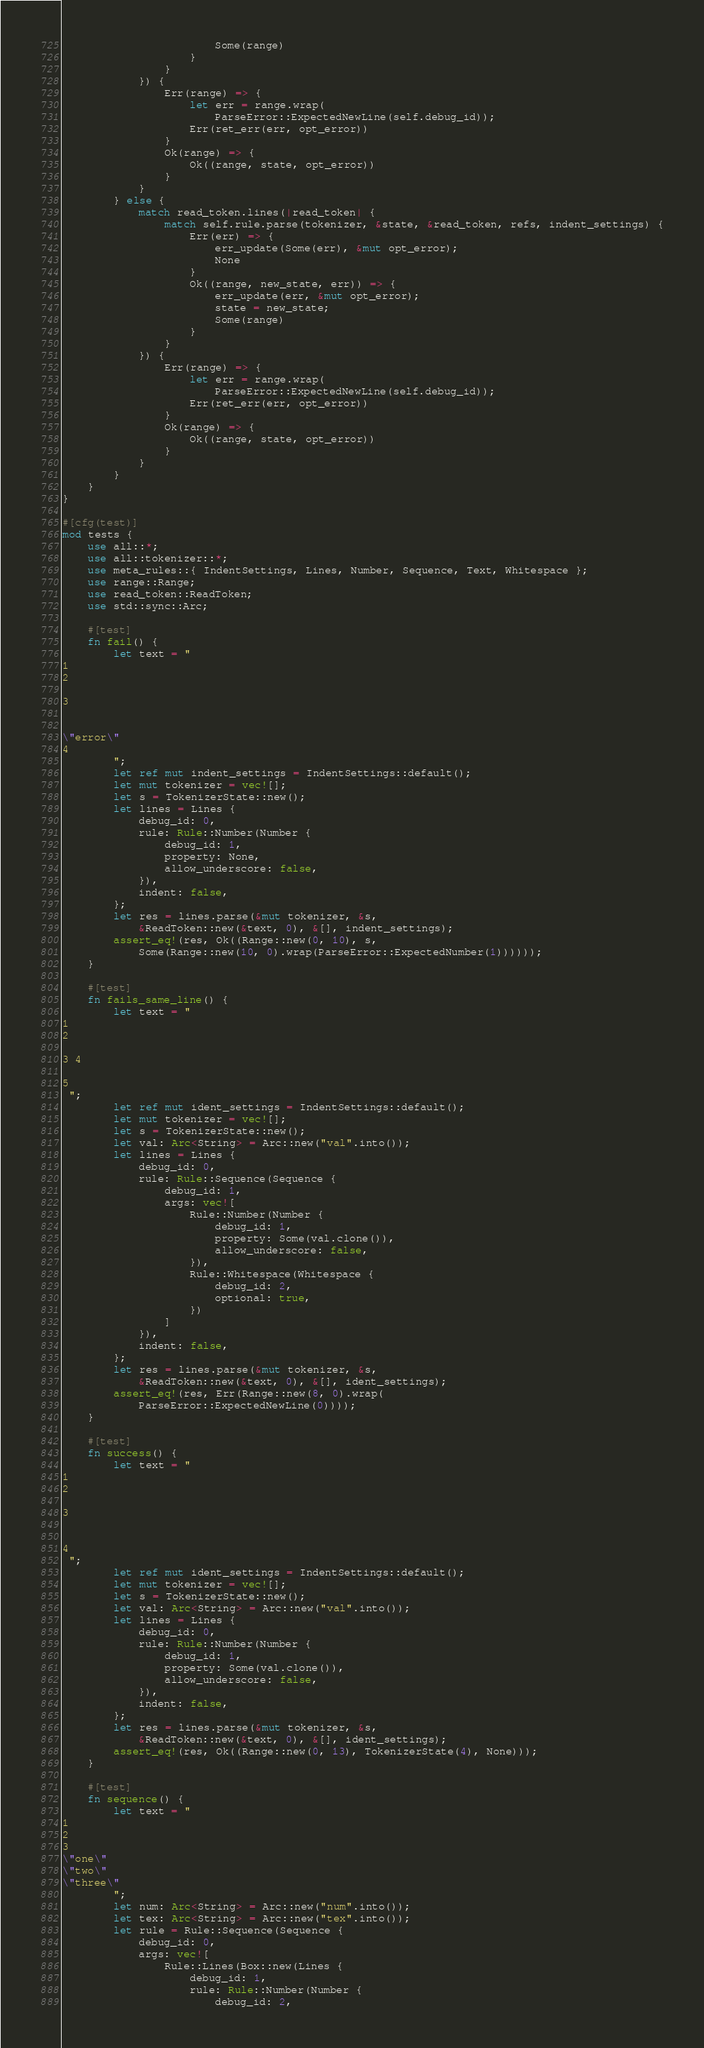<code> <loc_0><loc_0><loc_500><loc_500><_Rust_>                        Some(range)
                    }
                }
            }) {
                Err(range) => {
                    let err = range.wrap(
                        ParseError::ExpectedNewLine(self.debug_id));
                    Err(ret_err(err, opt_error))
                }
                Ok(range) => {
                    Ok((range, state, opt_error))
                }
            }
        } else {
            match read_token.lines(|read_token| {
                match self.rule.parse(tokenizer, &state, &read_token, refs, indent_settings) {
                    Err(err) => {
                        err_update(Some(err), &mut opt_error);
                        None
                    }
                    Ok((range, new_state, err)) => {
                        err_update(err, &mut opt_error);
                        state = new_state;
                        Some(range)
                    }
                }
            }) {
                Err(range) => {
                    let err = range.wrap(
                        ParseError::ExpectedNewLine(self.debug_id));
                    Err(ret_err(err, opt_error))
                }
                Ok(range) => {
                    Ok((range, state, opt_error))
                }
            }
        }
    }
}

#[cfg(test)]
mod tests {
    use all::*;
    use all::tokenizer::*;
    use meta_rules::{ IndentSettings, Lines, Number, Sequence, Text, Whitespace };
    use range::Range;
    use read_token::ReadToken;
    use std::sync::Arc;

    #[test]
    fn fail() {
        let text = "
1
2

3


\"error\"
4
        ";
        let ref mut indent_settings = IndentSettings::default();
        let mut tokenizer = vec![];
        let s = TokenizerState::new();
        let lines = Lines {
            debug_id: 0,
            rule: Rule::Number(Number {
                debug_id: 1,
                property: None,
                allow_underscore: false,
            }),
            indent: false,
        };
        let res = lines.parse(&mut tokenizer, &s,
            &ReadToken::new(&text, 0), &[], indent_settings);
        assert_eq!(res, Ok((Range::new(0, 10), s,
            Some(Range::new(10, 0).wrap(ParseError::ExpectedNumber(1))))));
    }

    #[test]
    fn fails_same_line() {
        let text = "
1
2

3 4

5
 ";
        let ref mut ident_settings = IndentSettings::default();
        let mut tokenizer = vec![];
        let s = TokenizerState::new();
        let val: Arc<String> = Arc::new("val".into());
        let lines = Lines {
            debug_id: 0,
            rule: Rule::Sequence(Sequence {
                debug_id: 1,
                args: vec![
                    Rule::Number(Number {
                        debug_id: 1,
                        property: Some(val.clone()),
                        allow_underscore: false,
                    }),
                    Rule::Whitespace(Whitespace {
                        debug_id: 2,
                        optional: true,
                    })
                ]
            }),
            indent: false,
        };
        let res = lines.parse(&mut tokenizer, &s,
            &ReadToken::new(&text, 0), &[], ident_settings);
        assert_eq!(res, Err(Range::new(8, 0).wrap(
            ParseError::ExpectedNewLine(0))));
    }

    #[test]
    fn success() {
        let text = "
1
2

3


4
 ";
        let ref mut ident_settings = IndentSettings::default();
        let mut tokenizer = vec![];
        let s = TokenizerState::new();
        let val: Arc<String> = Arc::new("val".into());
        let lines = Lines {
            debug_id: 0,
            rule: Rule::Number(Number {
                debug_id: 1,
                property: Some(val.clone()),
                allow_underscore: false,
            }),
            indent: false,
        };
        let res = lines.parse(&mut tokenizer, &s,
            &ReadToken::new(&text, 0), &[], ident_settings);
        assert_eq!(res, Ok((Range::new(0, 13), TokenizerState(4), None)));
    }

    #[test]
    fn sequence() {
        let text = "
1
2
3
\"one\"
\"two\"
\"three\"
        ";
        let num: Arc<String> = Arc::new("num".into());
        let tex: Arc<String> = Arc::new("tex".into());
        let rule = Rule::Sequence(Sequence {
            debug_id: 0,
            args: vec![
                Rule::Lines(Box::new(Lines {
                    debug_id: 1,
                    rule: Rule::Number(Number {
                        debug_id: 2,</code> 